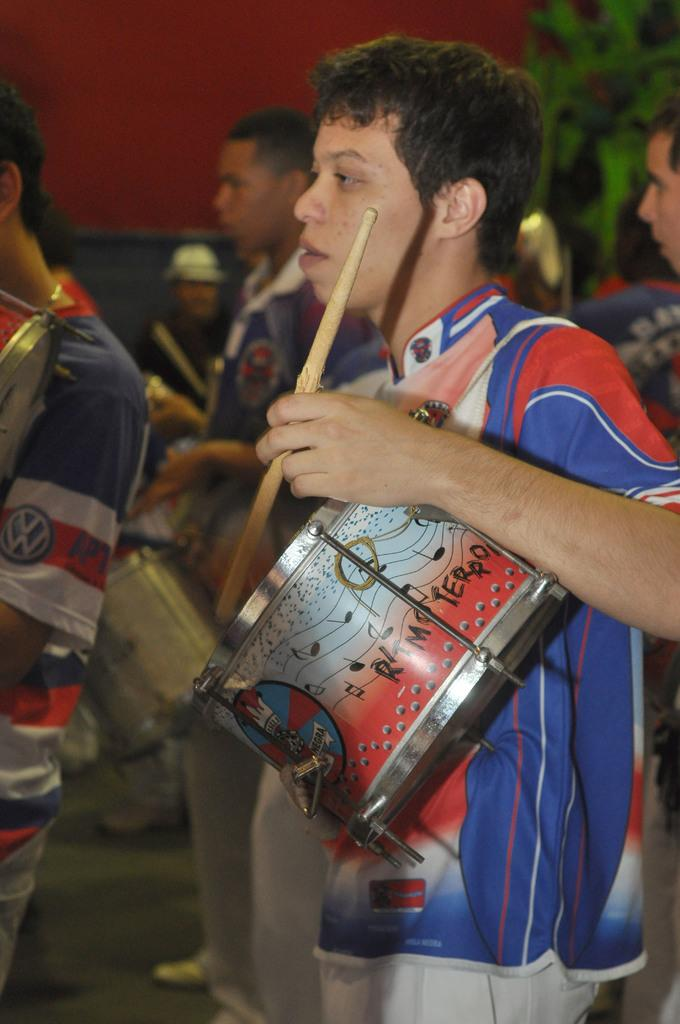Who or what is present in the image? There are people in the image. What are the people doing in the image? The people are playing musical instruments. Can you describe the background of the image? There is a plant in the background of the image. Are there any fairies playing musical instruments in the image? No, there are no fairies present in the image. What is the reason for the people playing musical instruments in the image? The facts provided do not give any information about the reason for the people playing musical instruments. 